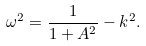Convert formula to latex. <formula><loc_0><loc_0><loc_500><loc_500>\omega ^ { 2 } = \frac { 1 } { 1 + A ^ { 2 } } - k ^ { 2 } .</formula> 